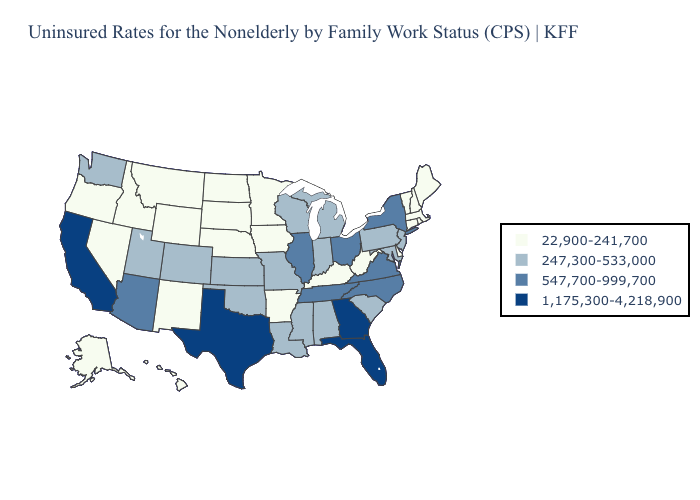What is the lowest value in the USA?
Keep it brief. 22,900-241,700. Which states have the lowest value in the Northeast?
Short answer required. Connecticut, Maine, Massachusetts, New Hampshire, Rhode Island, Vermont. Does the map have missing data?
Concise answer only. No. Does Texas have the lowest value in the USA?
Write a very short answer. No. What is the highest value in the South ?
Write a very short answer. 1,175,300-4,218,900. Among the states that border New Hampshire , which have the highest value?
Keep it brief. Maine, Massachusetts, Vermont. What is the value of Pennsylvania?
Concise answer only. 247,300-533,000. What is the value of North Carolina?
Be succinct. 547,700-999,700. Among the states that border Alabama , which have the lowest value?
Answer briefly. Mississippi. Does California have the same value as Colorado?
Answer briefly. No. What is the highest value in states that border Florida?
Answer briefly. 1,175,300-4,218,900. Does the map have missing data?
Be succinct. No. What is the value of Maine?
Write a very short answer. 22,900-241,700. What is the value of California?
Answer briefly. 1,175,300-4,218,900. Does Virginia have a higher value than New Hampshire?
Be succinct. Yes. 